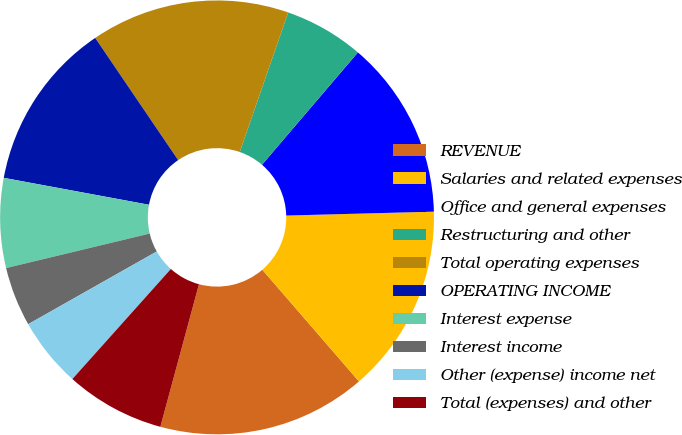Convert chart. <chart><loc_0><loc_0><loc_500><loc_500><pie_chart><fcel>REVENUE<fcel>Salaries and related expenses<fcel>Office and general expenses<fcel>Restructuring and other<fcel>Total operating expenses<fcel>OPERATING INCOME<fcel>Interest expense<fcel>Interest income<fcel>Other (expense) income net<fcel>Total (expenses) and other<nl><fcel>15.56%<fcel>14.07%<fcel>13.33%<fcel>5.93%<fcel>14.81%<fcel>12.59%<fcel>6.67%<fcel>4.44%<fcel>5.19%<fcel>7.41%<nl></chart> 